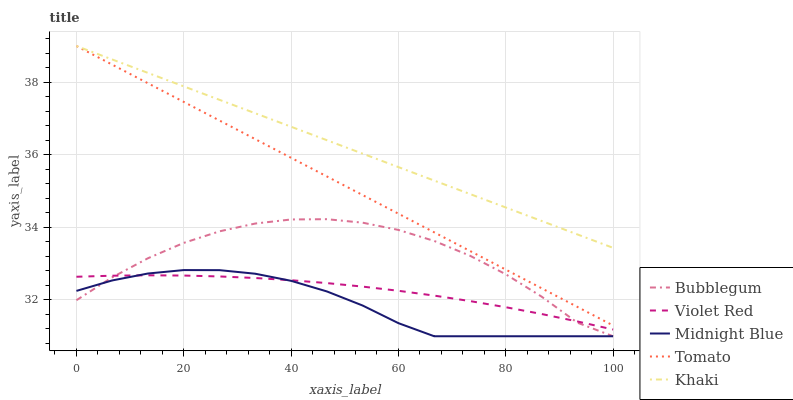Does Midnight Blue have the minimum area under the curve?
Answer yes or no. Yes. Does Khaki have the maximum area under the curve?
Answer yes or no. Yes. Does Violet Red have the minimum area under the curve?
Answer yes or no. No. Does Violet Red have the maximum area under the curve?
Answer yes or no. No. Is Tomato the smoothest?
Answer yes or no. Yes. Is Bubblegum the roughest?
Answer yes or no. Yes. Is Violet Red the smoothest?
Answer yes or no. No. Is Violet Red the roughest?
Answer yes or no. No. Does Midnight Blue have the lowest value?
Answer yes or no. Yes. Does Violet Red have the lowest value?
Answer yes or no. No. Does Khaki have the highest value?
Answer yes or no. Yes. Does Violet Red have the highest value?
Answer yes or no. No. Is Violet Red less than Khaki?
Answer yes or no. Yes. Is Tomato greater than Bubblegum?
Answer yes or no. Yes. Does Violet Red intersect Bubblegum?
Answer yes or no. Yes. Is Violet Red less than Bubblegum?
Answer yes or no. No. Is Violet Red greater than Bubblegum?
Answer yes or no. No. Does Violet Red intersect Khaki?
Answer yes or no. No. 